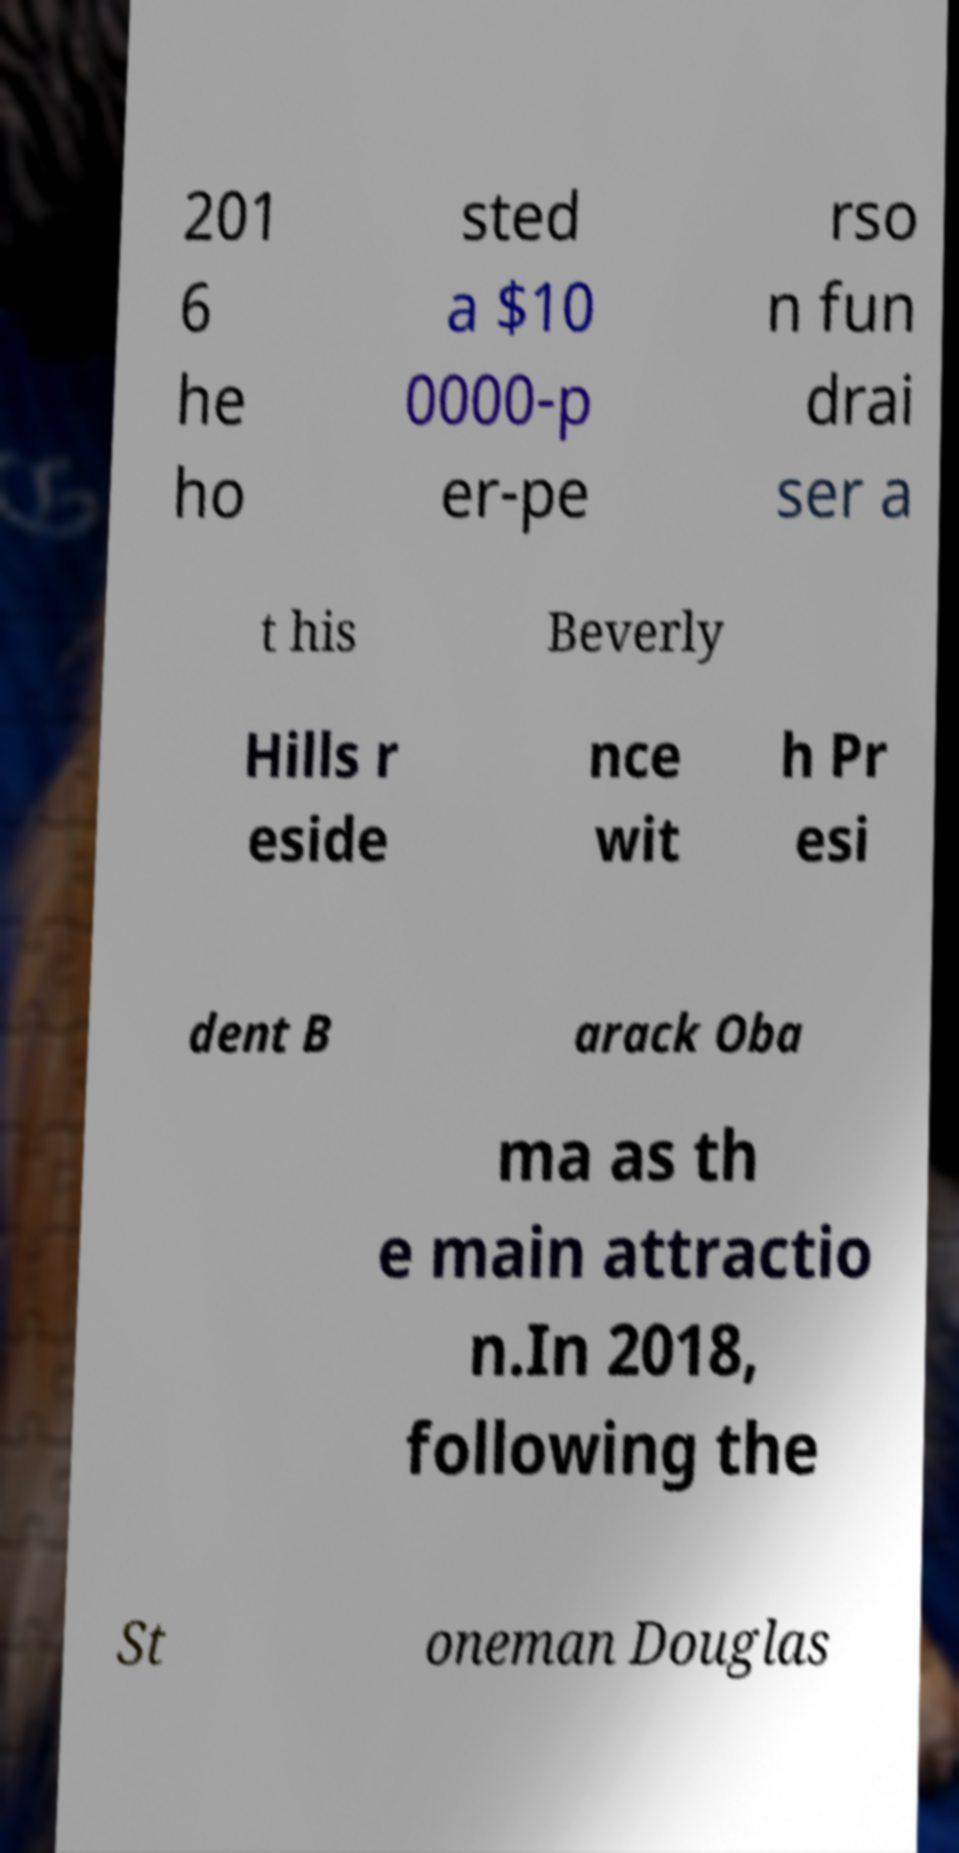Please read and relay the text visible in this image. What does it say? 201 6 he ho sted a $10 0000-p er-pe rso n fun drai ser a t his Beverly Hills r eside nce wit h Pr esi dent B arack Oba ma as th e main attractio n.In 2018, following the St oneman Douglas 